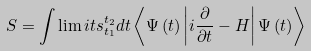<formula> <loc_0><loc_0><loc_500><loc_500>S = \int \lim i t s _ { t _ { 1 } } ^ { t _ { 2 } } { d t \left \langle { \Psi \left ( t \right ) \left | { i \frac { \partial } { \partial t } - H } \right | \Psi \left ( t \right ) } \right \rangle }</formula> 